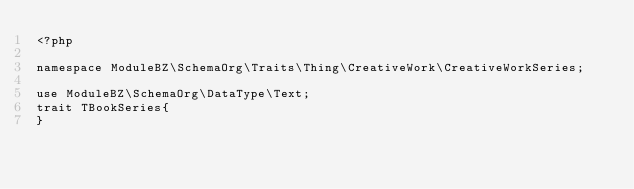<code> <loc_0><loc_0><loc_500><loc_500><_PHP_><?php

namespace ModuleBZ\SchemaOrg\Traits\Thing\CreativeWork\CreativeWorkSeries;

use ModuleBZ\SchemaOrg\DataType\Text;
trait TBookSeries{
}</code> 